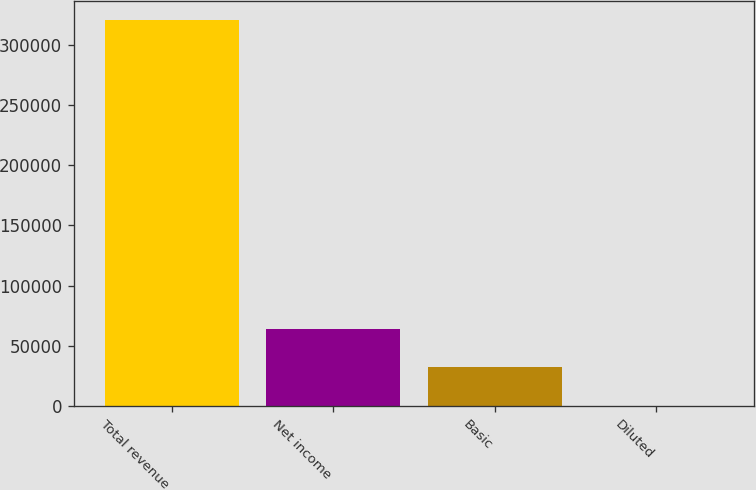Convert chart to OTSL. <chart><loc_0><loc_0><loc_500><loc_500><bar_chart><fcel>Total revenue<fcel>Net income<fcel>Basic<fcel>Diluted<nl><fcel>320614<fcel>64123.3<fcel>32062<fcel>0.65<nl></chart> 